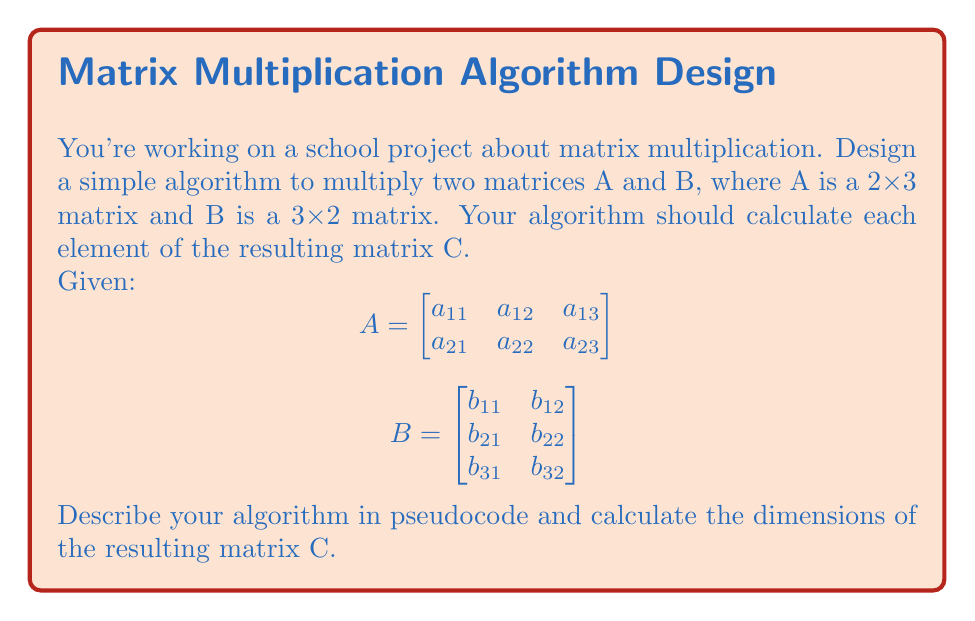Give your solution to this math problem. To develop a simple algorithm for matrix multiplication, we need to follow these steps:

1. Determine the dimensions of the resulting matrix:
   - Matrix A is 2x3 and matrix B is 3x2
   - The resulting matrix C will have dimensions 2x2

2. Create a nested loop structure to iterate through the elements of the resulting matrix:
   - Outer loop: rows of matrix A
   - Inner loop: columns of matrix B

3. For each element in C, calculate the dot product of the corresponding row in A and column in B

Here's the pseudocode for the algorithm:

```
function MatrixMultiply(A, B):
    m = number of rows in A
    n = number of columns in B
    p = number of columns in A (= number of rows in B)
    
    Initialize C as a new m x n matrix
    
    for i = 1 to m:
        for j = 1 to n:
            C[i][j] = 0
            for k = 1 to p:
                C[i][j] = C[i][j] + A[i][k] * B[k][j]
    
    return C
```

For our specific case:
- m = 2 (rows of A)
- n = 2 (columns of B)
- p = 3 (columns of A = rows of B)

The resulting matrix C will be:

$$C = \begin{bmatrix}
c_{11} & c_{12} \\
c_{21} & c_{22}
\end{bmatrix}$$

Where:
$$c_{11} = a_{11}b_{11} + a_{12}b_{21} + a_{13}b_{31}$$
$$c_{12} = a_{11}b_{12} + a_{12}b_{22} + a_{13}b_{32}$$
$$c_{21} = a_{21}b_{11} + a_{22}b_{21} + a_{23}b_{31}$$
$$c_{22} = a_{21}b_{12} + a_{22}b_{22} + a_{23}b_{32}$$

The dimensions of the resulting matrix C are 2x2.
Answer: Algorithm: Nested loops (i,j,k) to compute $C_{ij} = \sum_{k=1}^p A_{ik}B_{kj}$. Resulting matrix C: 2x2. 